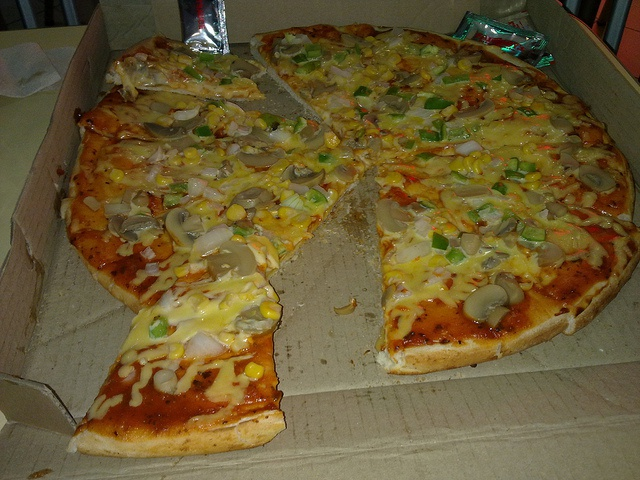Describe the objects in this image and their specific colors. I can see pizza in black, olive, and maroon tones, pizza in black, olive, maroon, and tan tones, pizza in black, olive, and maroon tones, pizza in black, olive, maroon, and gray tones, and pizza in black, maroon, olive, and gray tones in this image. 